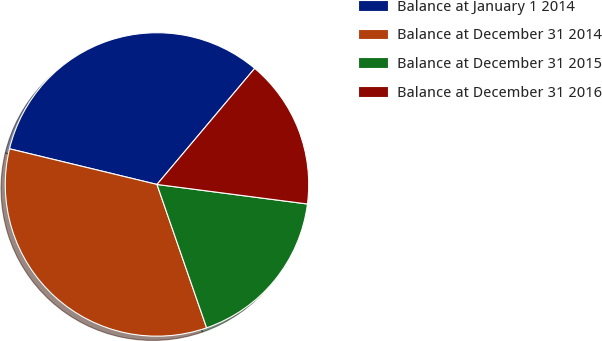<chart> <loc_0><loc_0><loc_500><loc_500><pie_chart><fcel>Balance at January 1 2014<fcel>Balance at December 31 2014<fcel>Balance at December 31 2015<fcel>Balance at December 31 2016<nl><fcel>32.36%<fcel>34.08%<fcel>17.64%<fcel>15.92%<nl></chart> 